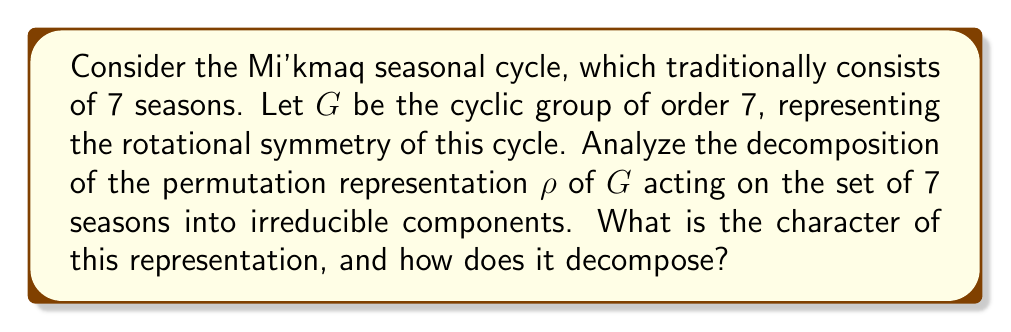Could you help me with this problem? Let's approach this step-by-step:

1) The group $G$ is cyclic of order 7, so it has 7 irreducible representations, each of dimension 1. Let's call them $\chi_0, \chi_1, ..., \chi_6$, where $\chi_0$ is the trivial representation.

2) For a cyclic group of order $n$, the character of the $k$-th irreducible representation is given by:

   $$\chi_k(g^j) = e^{2\pi i kj/n}$$

   where $g$ is a generator of the group.

3) The character of the permutation representation $\rho$ is given by the number of fixed points for each group element. Let's call this character $\chi_\rho$. We have:

   $$\chi_\rho(g^0) = 7$$
   $$\chi_\rho(g^j) = 1$$ for $j = 1, 2, ..., 6$

   This is because the identity element fixes all 7 seasons, while any non-trivial rotation fixes only the "center" of the cycle.

4) To decompose $\rho$, we need to compute the inner product of $\chi_\rho$ with each irreducible character $\chi_k$:

   $$\langle \chi_\rho, \chi_k \rangle = \frac{1}{7} \sum_{j=0}^6 \chi_\rho(g^j) \overline{\chi_k(g^j)}$$

5) For $k = 0$ (the trivial representation):

   $$\langle \chi_\rho, \chi_0 \rangle = \frac{1}{7}(7 + 1 + 1 + 1 + 1 + 1 + 1) = 1$$

6) For $k \neq 0$:

   $$\langle \chi_\rho, \chi_k \rangle = \frac{1}{7}(7 + e^{-2\pi i k/7} + e^{-4\pi i k/7} + ... + e^{-12\pi i k/7})$$

   This sum equals 1 for all $k \neq 0$, because the sum of all 7th roots of unity is 0.

7) Therefore, the decomposition of $\rho$ is:

   $$\rho \cong \chi_0 \oplus \chi_1 \oplus \chi_2 \oplus \chi_3 \oplus \chi_4 \oplus \chi_5 \oplus \chi_6$$
Answer: $\chi_\rho = (7,1,1,1,1,1,1)$; $\rho \cong \bigoplus_{k=0}^6 \chi_k$ 